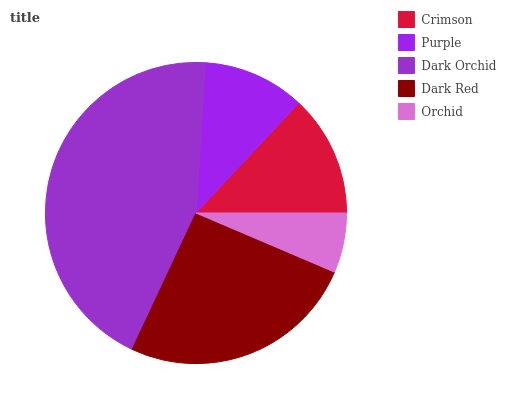Is Orchid the minimum?
Answer yes or no. Yes. Is Dark Orchid the maximum?
Answer yes or no. Yes. Is Purple the minimum?
Answer yes or no. No. Is Purple the maximum?
Answer yes or no. No. Is Crimson greater than Purple?
Answer yes or no. Yes. Is Purple less than Crimson?
Answer yes or no. Yes. Is Purple greater than Crimson?
Answer yes or no. No. Is Crimson less than Purple?
Answer yes or no. No. Is Crimson the high median?
Answer yes or no. Yes. Is Crimson the low median?
Answer yes or no. Yes. Is Orchid the high median?
Answer yes or no. No. Is Dark Orchid the low median?
Answer yes or no. No. 